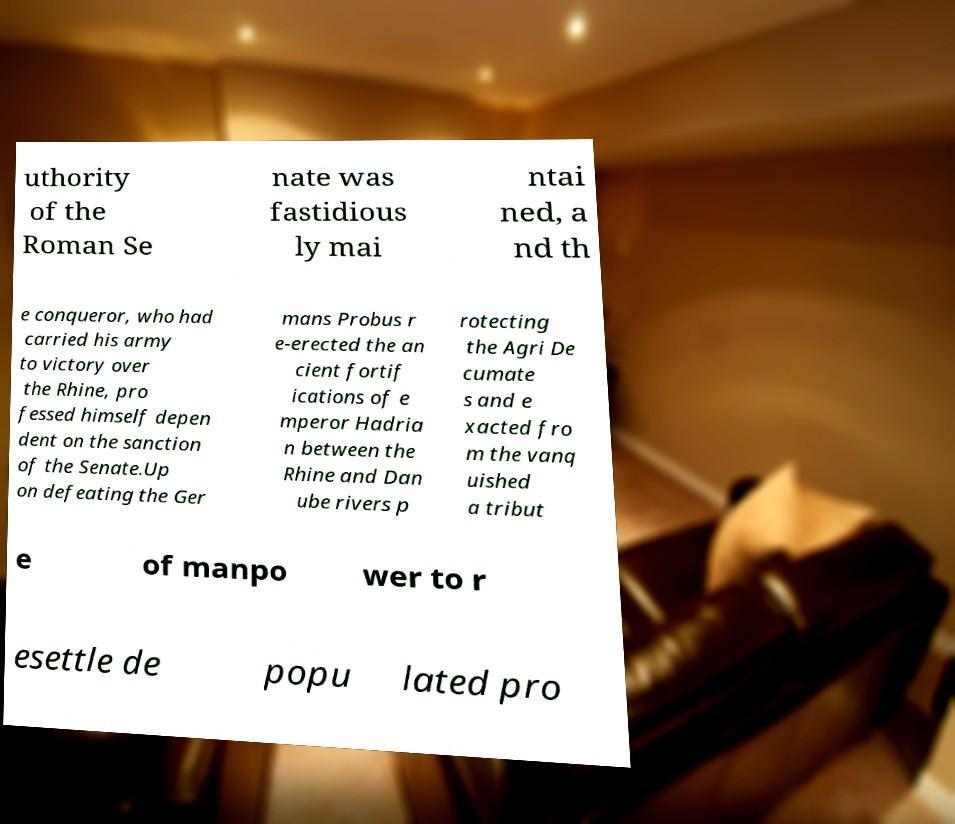Could you assist in decoding the text presented in this image and type it out clearly? uthority of the Roman Se nate was fastidious ly mai ntai ned, a nd th e conqueror, who had carried his army to victory over the Rhine, pro fessed himself depen dent on the sanction of the Senate.Up on defeating the Ger mans Probus r e-erected the an cient fortif ications of e mperor Hadria n between the Rhine and Dan ube rivers p rotecting the Agri De cumate s and e xacted fro m the vanq uished a tribut e of manpo wer to r esettle de popu lated pro 